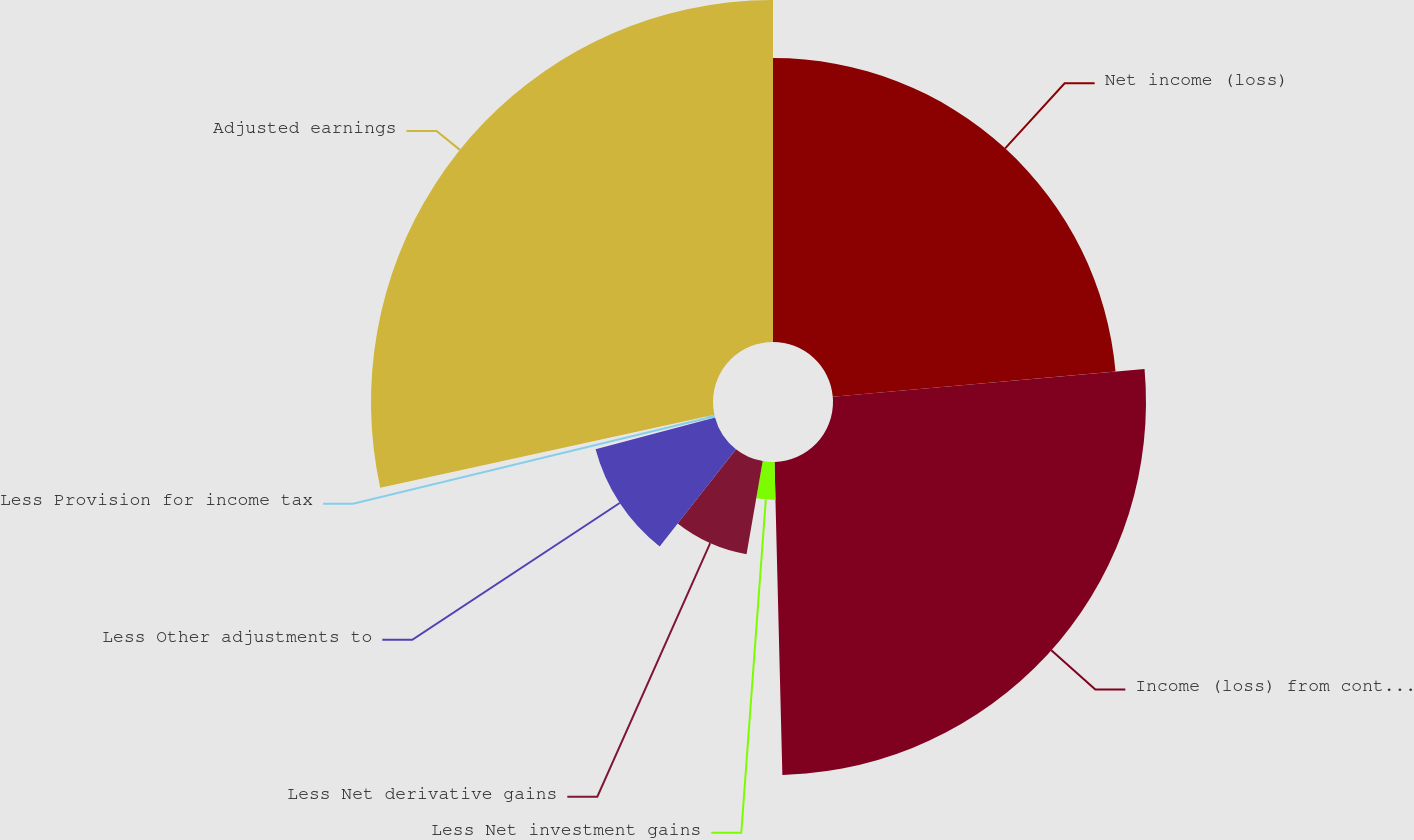Convert chart to OTSL. <chart><loc_0><loc_0><loc_500><loc_500><pie_chart><fcel>Net income (loss)<fcel>Income (loss) from continuing<fcel>Less Net investment gains<fcel>Less Net derivative gains<fcel>Less Other adjustments to<fcel>Less Provision for income tax<fcel>Adjusted earnings<nl><fcel>23.59%<fcel>26.01%<fcel>3.14%<fcel>7.85%<fcel>10.27%<fcel>0.72%<fcel>28.42%<nl></chart> 